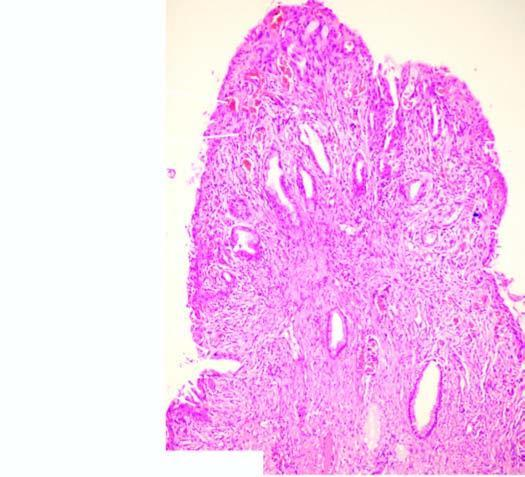what is the stromal core composed of?
Answer the question using a single word or phrase. Dense fibrous tissue which shows nonspecific inflammation 